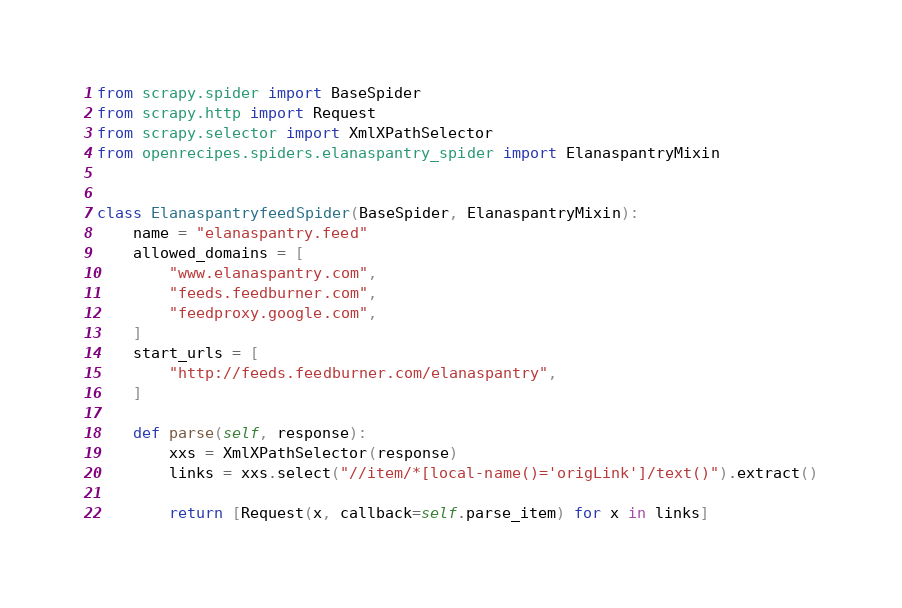Convert code to text. <code><loc_0><loc_0><loc_500><loc_500><_Python_>from scrapy.spider import BaseSpider
from scrapy.http import Request
from scrapy.selector import XmlXPathSelector
from openrecipes.spiders.elanaspantry_spider import ElanaspantryMixin


class ElanaspantryfeedSpider(BaseSpider, ElanaspantryMixin):
    name = "elanaspantry.feed"
    allowed_domains = [
        "www.elanaspantry.com",
        "feeds.feedburner.com",
        "feedproxy.google.com",
    ]
    start_urls = [
        "http://feeds.feedburner.com/elanaspantry",
    ]

    def parse(self, response):
        xxs = XmlXPathSelector(response)
        links = xxs.select("//item/*[local-name()='origLink']/text()").extract()

        return [Request(x, callback=self.parse_item) for x in links]
</code> 